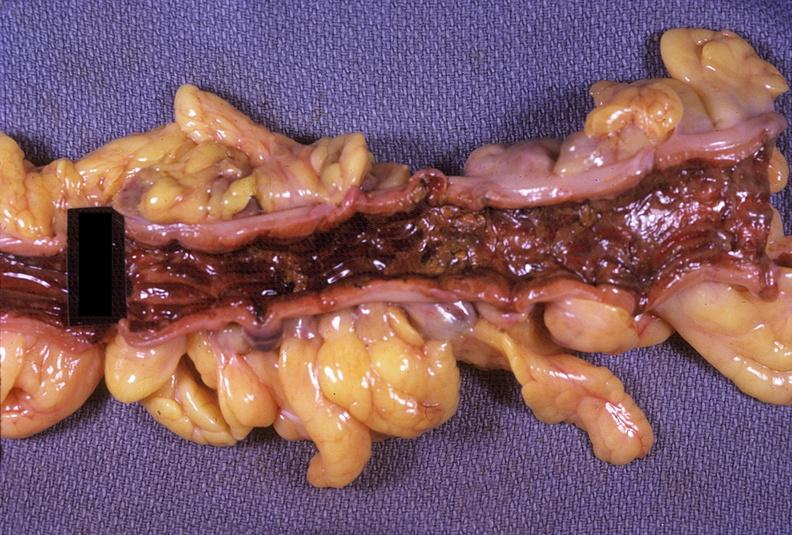s cyst present?
Answer the question using a single word or phrase. No 